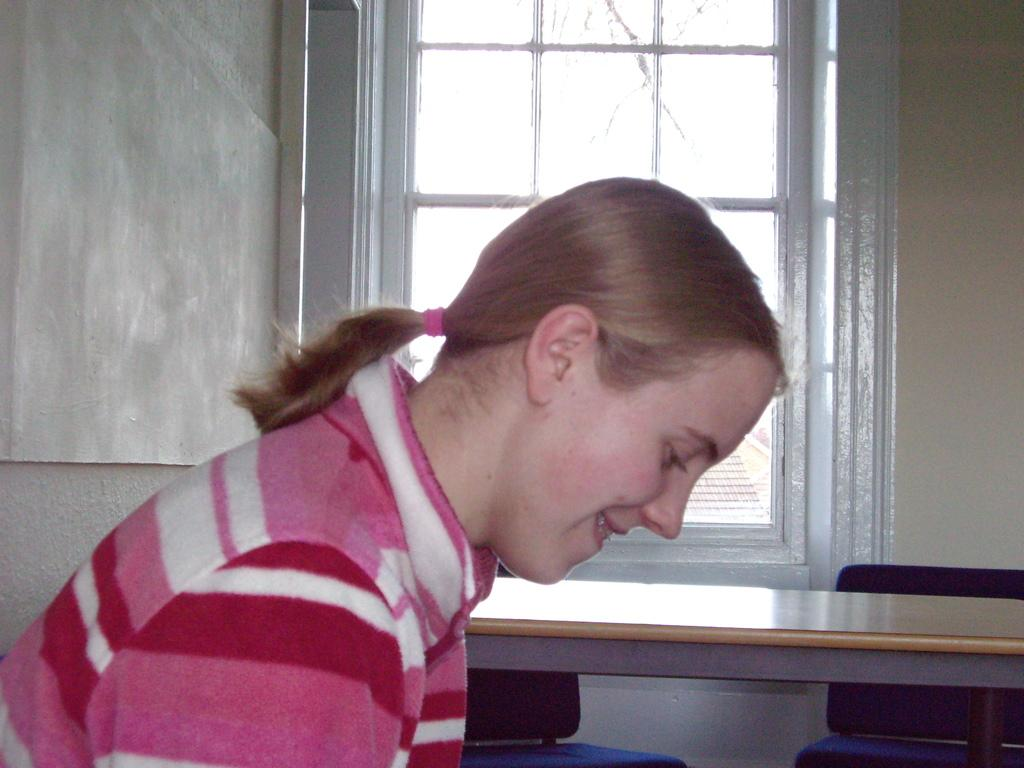Who is present in the image? There is a woman in the image. What is the woman wearing? The woman is wearing a pink dress. What expression does the woman have the woman in the image? The woman is smiling. How would you describe the woman's hairstyle? The woman has short hair. What can be seen in the background of the image? There is a table, two chairs, a window, and a wall in the background of the image. What type of beetle can be seen crawling on the woman's dress in the image? There is no beetle present on the woman's dress in the image. What type of horse is depicted in the background of the image? There is no horse present in the image; it only features a woman, a table, chairs, a window, and a wall in the background. 